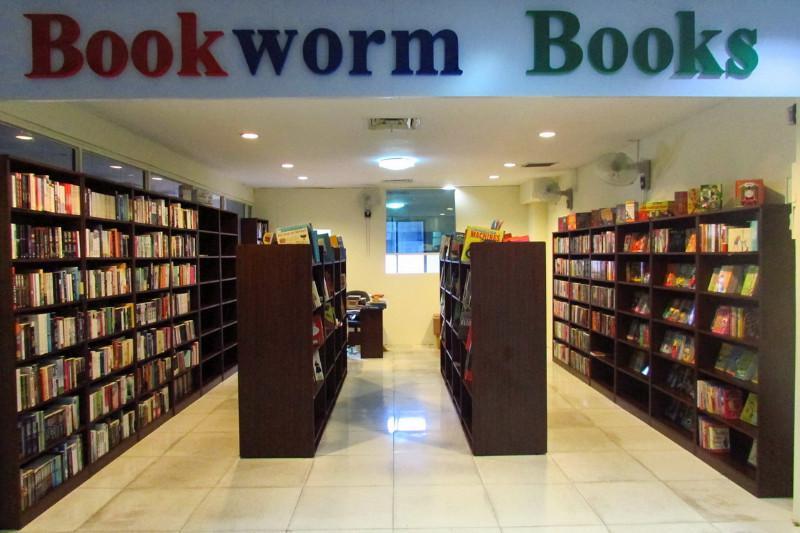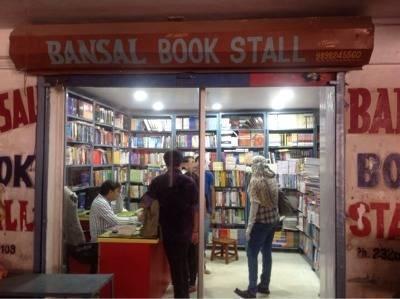The first image is the image on the left, the second image is the image on the right. Considering the images on both sides, is "There is no human inside a store in the left image." valid? Answer yes or no. Yes. The first image is the image on the left, the second image is the image on the right. Assess this claim about the two images: "The signage for the store can only be seen in one of the images.". Correct or not? Answer yes or no. No. 